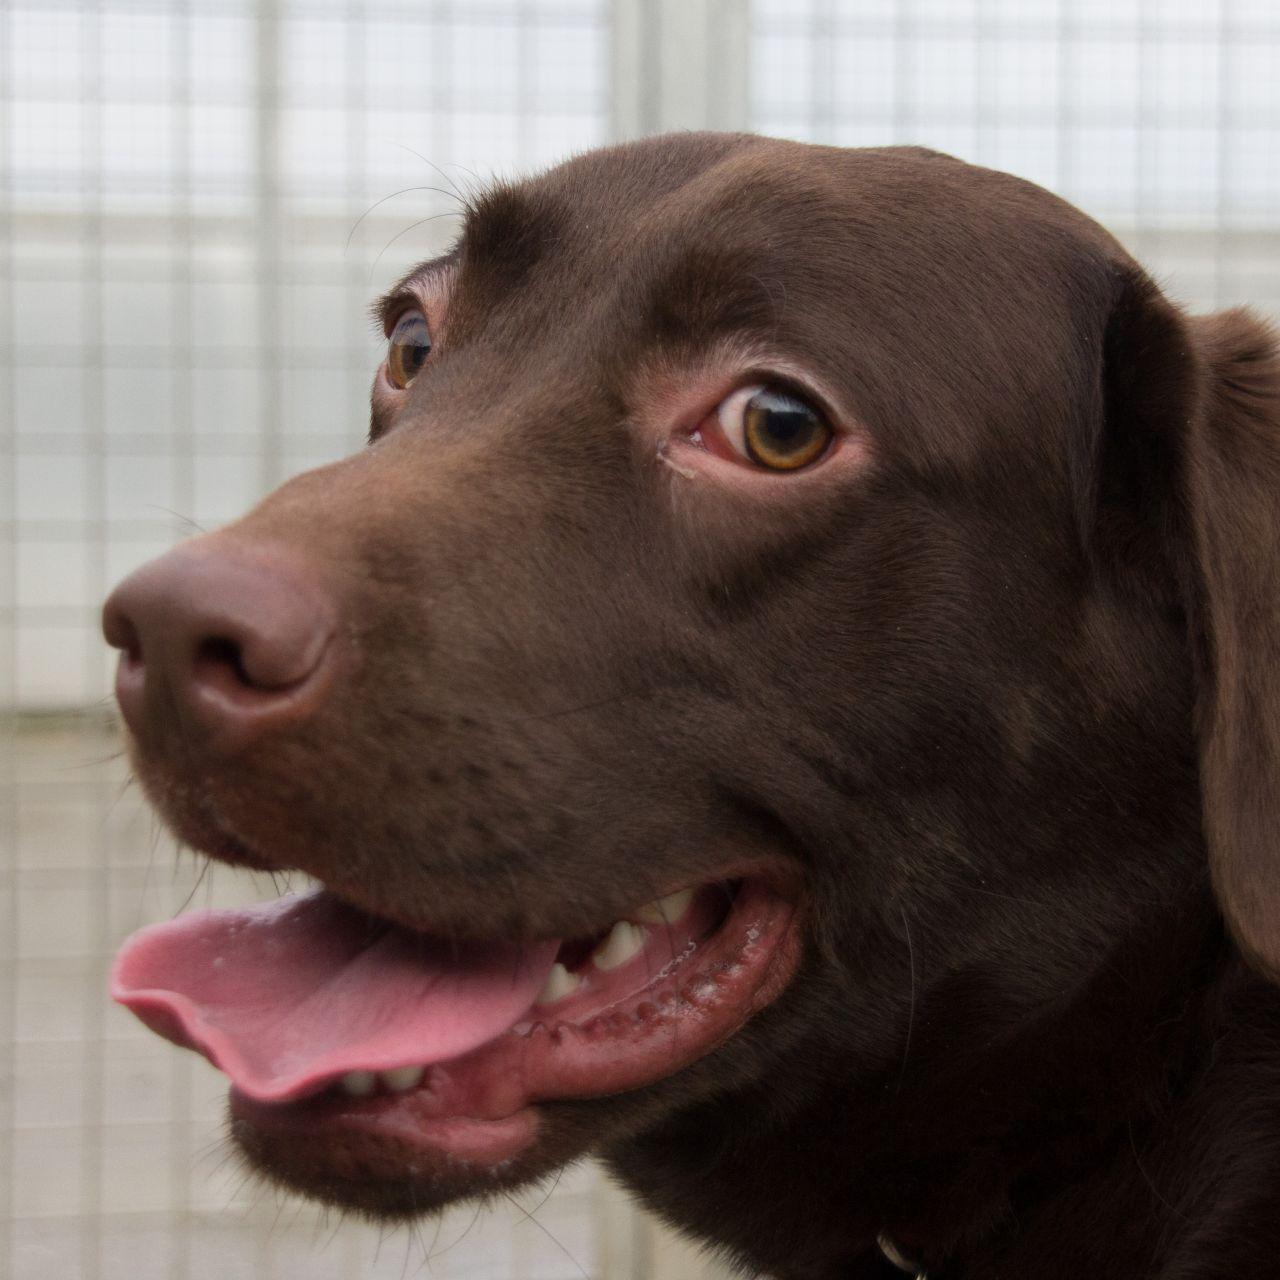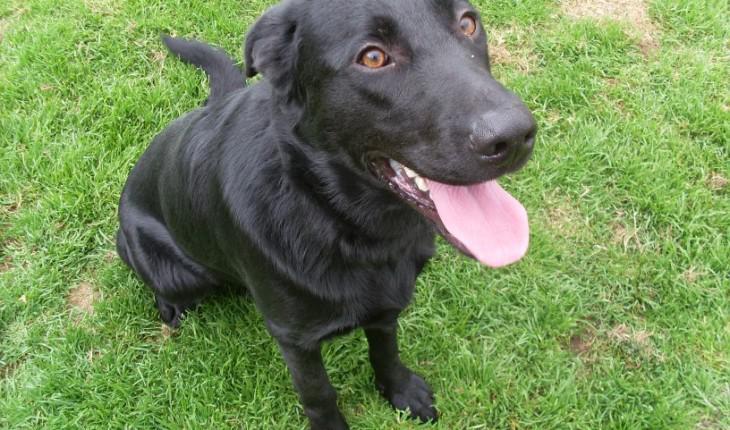The first image is the image on the left, the second image is the image on the right. Examine the images to the left and right. Is the description "There's one black lab and one chocolate lab." accurate? Answer yes or no. Yes. The first image is the image on the left, the second image is the image on the right. Analyze the images presented: Is the assertion "A dog appears to be lying down." valid? Answer yes or no. No. 